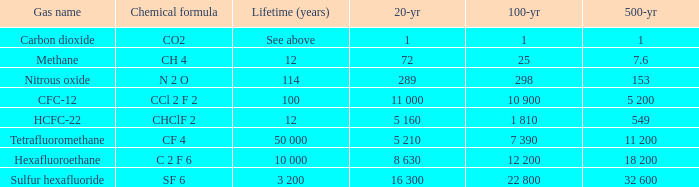If 20 years is equivalent to 289, what would be the 500-year duration? 153.0. 